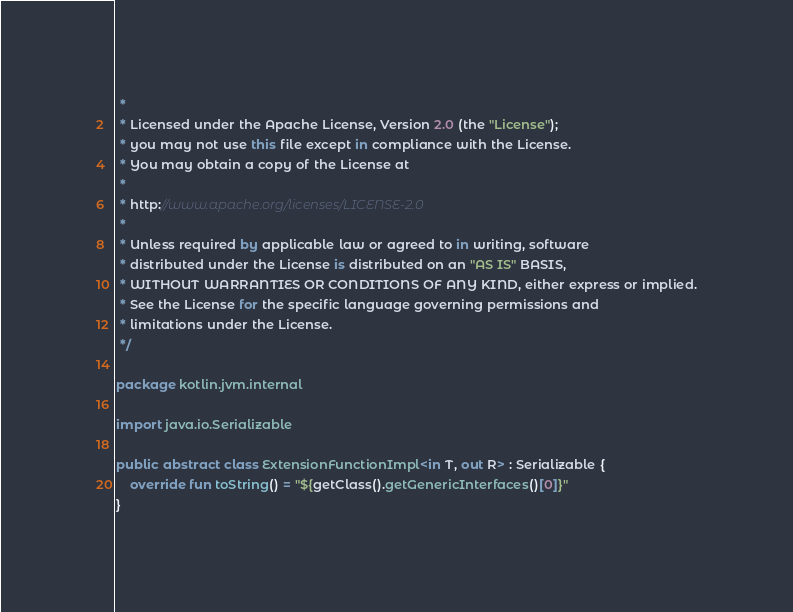<code> <loc_0><loc_0><loc_500><loc_500><_Kotlin_> *
 * Licensed under the Apache License, Version 2.0 (the "License");
 * you may not use this file except in compliance with the License.
 * You may obtain a copy of the License at
 *
 * http://www.apache.org/licenses/LICENSE-2.0
 *
 * Unless required by applicable law or agreed to in writing, software
 * distributed under the License is distributed on an "AS IS" BASIS,
 * WITHOUT WARRANTIES OR CONDITIONS OF ANY KIND, either express or implied.
 * See the License for the specific language governing permissions and
 * limitations under the License.
 */

package kotlin.jvm.internal

import java.io.Serializable

public abstract class ExtensionFunctionImpl<in T, out R> : Serializable {
    override fun toString() = "${getClass().getGenericInterfaces()[0]}"
}
</code> 